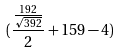Convert formula to latex. <formula><loc_0><loc_0><loc_500><loc_500>( \frac { \frac { 1 9 2 } { \sqrt { 3 9 2 } } } { 2 } + 1 5 9 - 4 )</formula> 